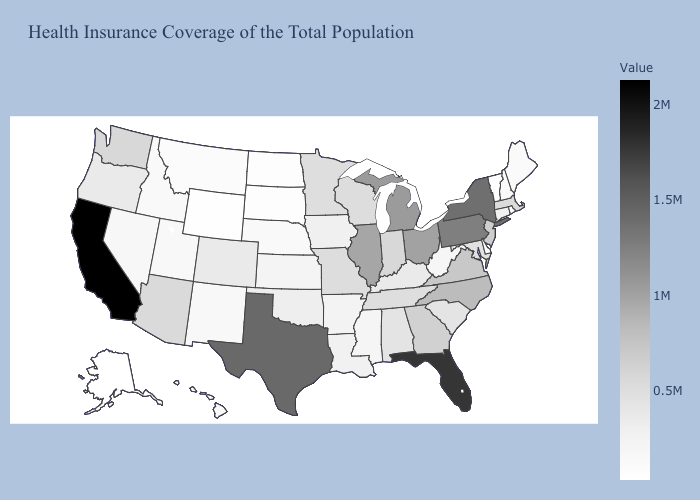Among the states that border California , does Oregon have the lowest value?
Keep it brief. No. Does Nevada have the lowest value in the USA?
Write a very short answer. No. Does California have the highest value in the USA?
Keep it brief. Yes. Is the legend a continuous bar?
Give a very brief answer. Yes. Does the map have missing data?
Be succinct. No. 